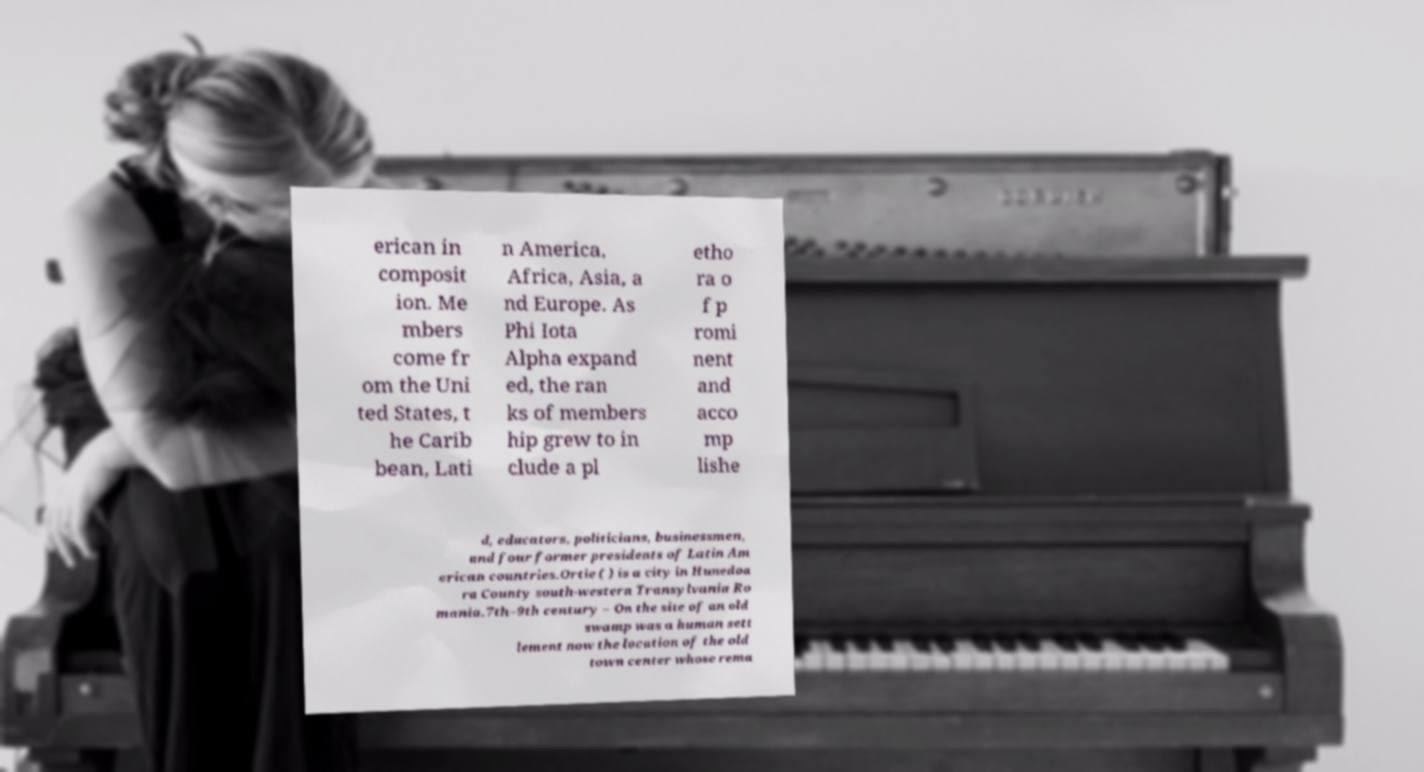Can you accurately transcribe the text from the provided image for me? erican in composit ion. Me mbers come fr om the Uni ted States, t he Carib bean, Lati n America, Africa, Asia, a nd Europe. As Phi Iota Alpha expand ed, the ran ks of members hip grew to in clude a pl etho ra o f p romi nent and acco mp lishe d, educators, politicians, businessmen, and four former presidents of Latin Am erican countries.Ortie ( ) is a city in Hunedoa ra County south-western Transylvania Ro mania.7th–9th century – On the site of an old swamp was a human sett lement now the location of the old town center whose rema 